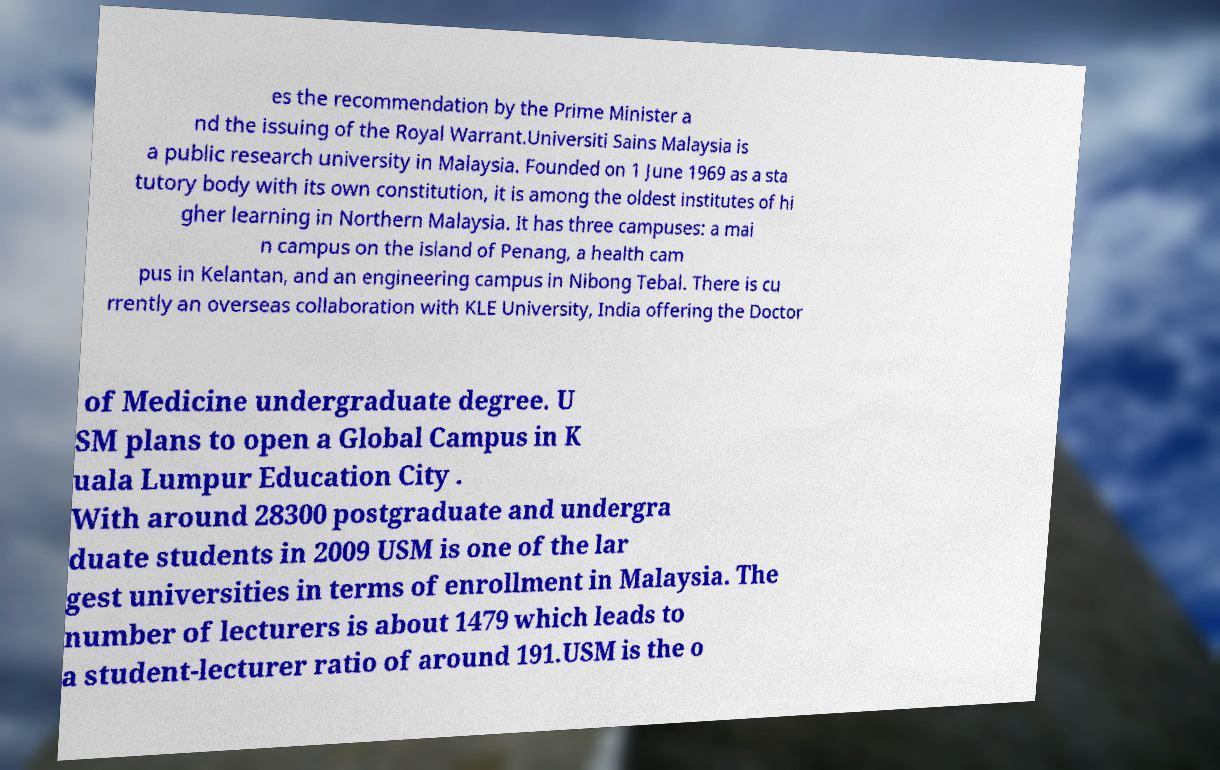Could you assist in decoding the text presented in this image and type it out clearly? es the recommendation by the Prime Minister a nd the issuing of the Royal Warrant.Universiti Sains Malaysia is a public research university in Malaysia. Founded on 1 June 1969 as a sta tutory body with its own constitution, it is among the oldest institutes of hi gher learning in Northern Malaysia. It has three campuses: a mai n campus on the island of Penang, a health cam pus in Kelantan, and an engineering campus in Nibong Tebal. There is cu rrently an overseas collaboration with KLE University, India offering the Doctor of Medicine undergraduate degree. U SM plans to open a Global Campus in K uala Lumpur Education City . With around 28300 postgraduate and undergra duate students in 2009 USM is one of the lar gest universities in terms of enrollment in Malaysia. The number of lecturers is about 1479 which leads to a student-lecturer ratio of around 191.USM is the o 